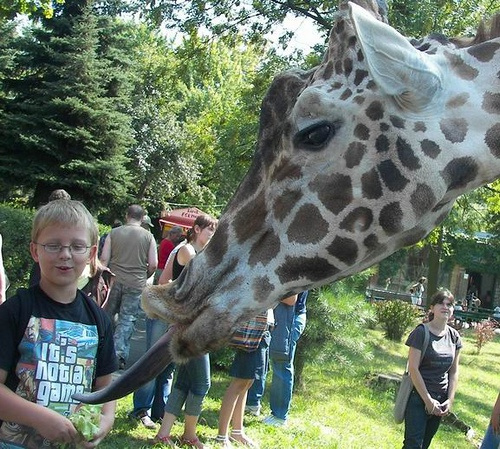Describe the objects in this image and their specific colors. I can see giraffe in darkgreen, gray, darkgray, and black tones, people in darkgreen, gray, black, darkgray, and lightblue tones, people in darkgreen, black, gray, lightgray, and darkgray tones, people in darkgreen, gray, darkgray, blue, and black tones, and people in darkgreen, blue, teal, darkblue, and ivory tones in this image. 